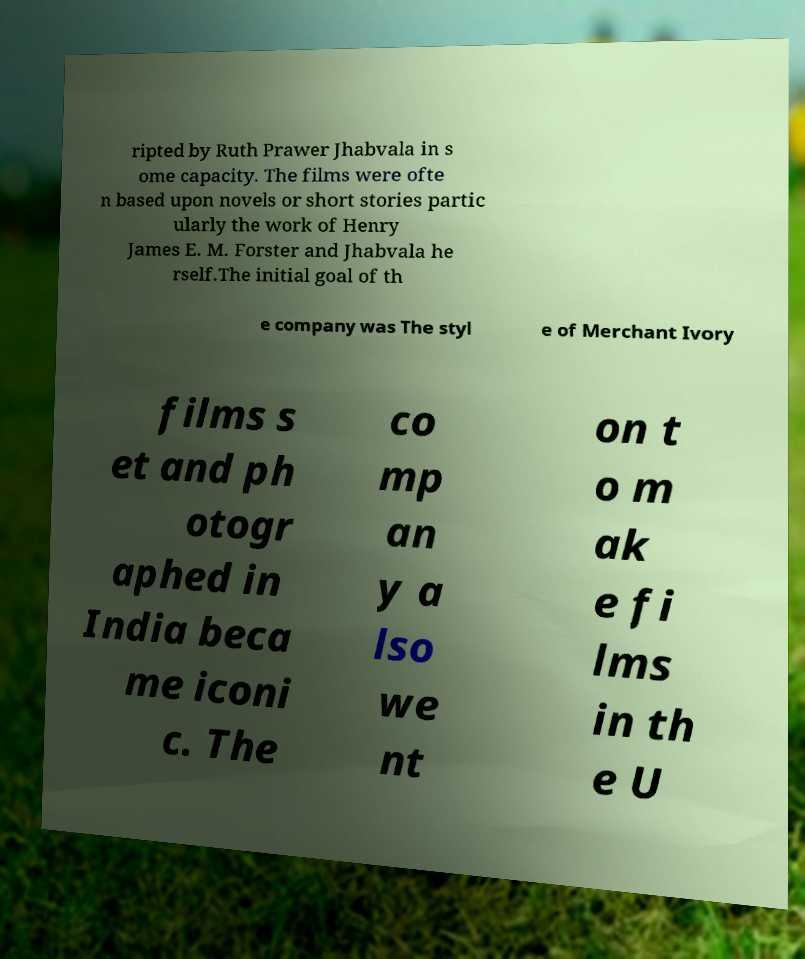For documentation purposes, I need the text within this image transcribed. Could you provide that? ripted by Ruth Prawer Jhabvala in s ome capacity. The films were ofte n based upon novels or short stories partic ularly the work of Henry James E. M. Forster and Jhabvala he rself.The initial goal of th e company was The styl e of Merchant Ivory films s et and ph otogr aphed in India beca me iconi c. The co mp an y a lso we nt on t o m ak e fi lms in th e U 